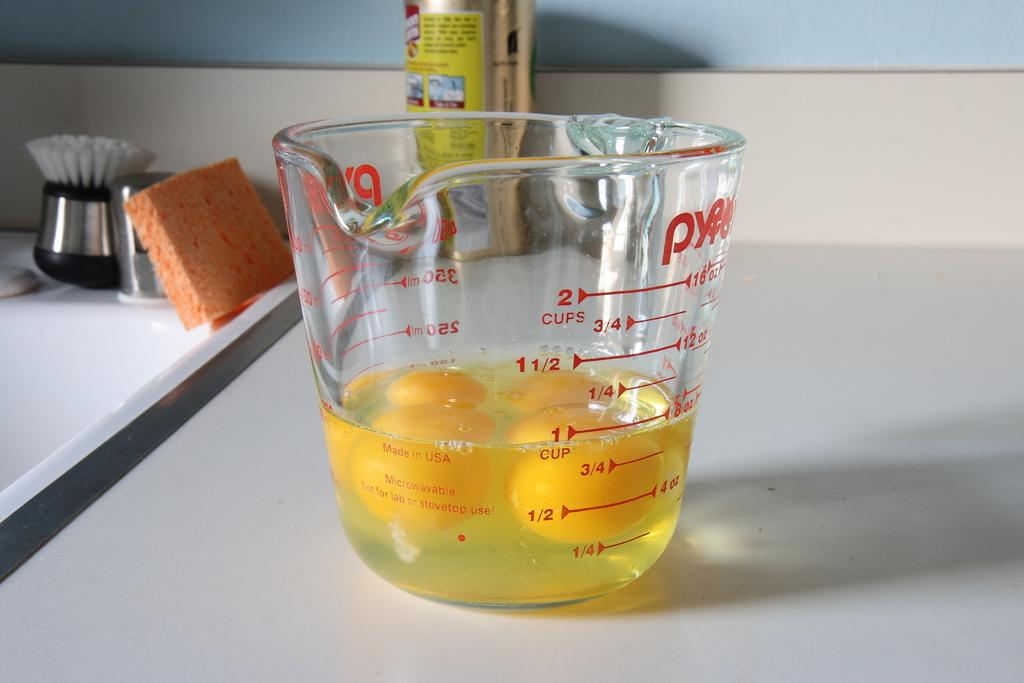<image>
Present a compact description of the photo's key features. A classic Pyrex measuring cup sits on a counter with 1 cup of cracked eggs inside 